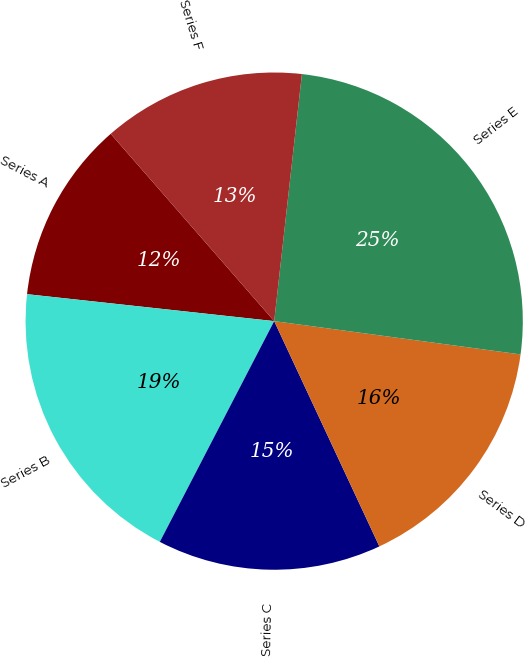<chart> <loc_0><loc_0><loc_500><loc_500><pie_chart><fcel>Series A<fcel>Series B<fcel>Series C<fcel>Series D<fcel>Series E<fcel>Series F<nl><fcel>11.85%<fcel>19.12%<fcel>14.56%<fcel>15.91%<fcel>25.36%<fcel>13.2%<nl></chart> 